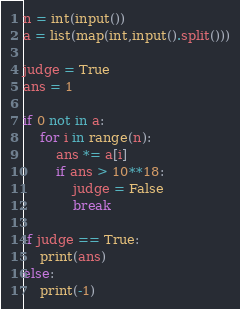<code> <loc_0><loc_0><loc_500><loc_500><_Python_>n = int(input())
a = list(map(int,input().split()))

judge = True
ans = 1

if 0 not in a:
    for i in range(n):
        ans *= a[i]
        if ans > 10**18:
            judge = False
            break
        
if judge == True:
    print(ans)
else:
    print(-1)</code> 